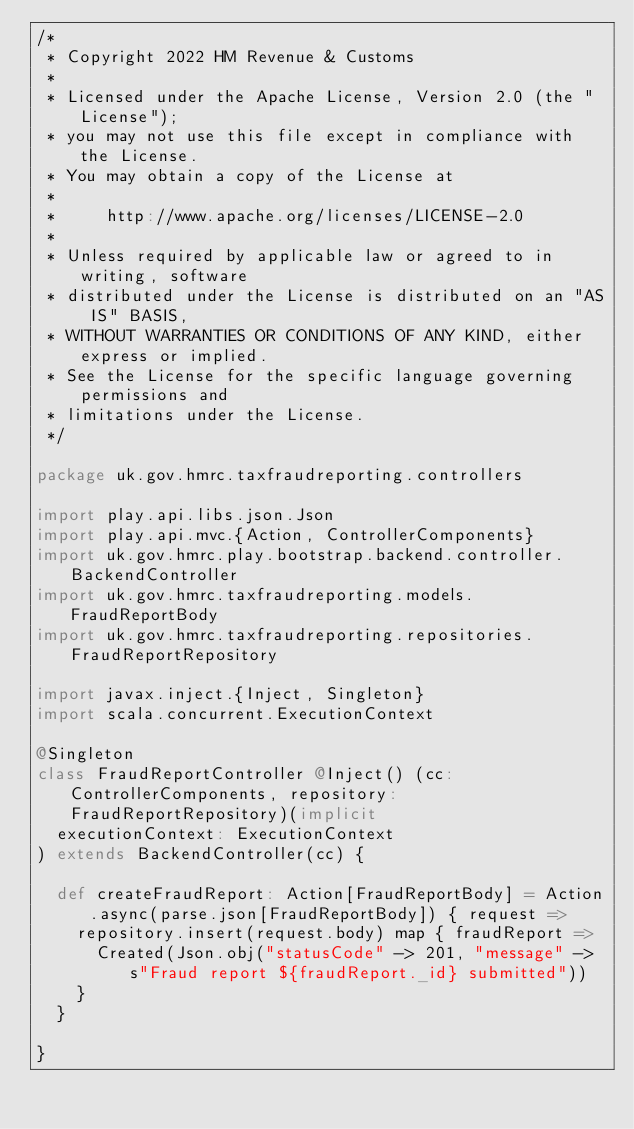<code> <loc_0><loc_0><loc_500><loc_500><_Scala_>/*
 * Copyright 2022 HM Revenue & Customs
 *
 * Licensed under the Apache License, Version 2.0 (the "License");
 * you may not use this file except in compliance with the License.
 * You may obtain a copy of the License at
 *
 *     http://www.apache.org/licenses/LICENSE-2.0
 *
 * Unless required by applicable law or agreed to in writing, software
 * distributed under the License is distributed on an "AS IS" BASIS,
 * WITHOUT WARRANTIES OR CONDITIONS OF ANY KIND, either express or implied.
 * See the License for the specific language governing permissions and
 * limitations under the License.
 */

package uk.gov.hmrc.taxfraudreporting.controllers

import play.api.libs.json.Json
import play.api.mvc.{Action, ControllerComponents}
import uk.gov.hmrc.play.bootstrap.backend.controller.BackendController
import uk.gov.hmrc.taxfraudreporting.models.FraudReportBody
import uk.gov.hmrc.taxfraudreporting.repositories.FraudReportRepository

import javax.inject.{Inject, Singleton}
import scala.concurrent.ExecutionContext

@Singleton
class FraudReportController @Inject() (cc: ControllerComponents, repository: FraudReportRepository)(implicit
  executionContext: ExecutionContext
) extends BackendController(cc) {

  def createFraudReport: Action[FraudReportBody] = Action.async(parse.json[FraudReportBody]) { request =>
    repository.insert(request.body) map { fraudReport =>
      Created(Json.obj("statusCode" -> 201, "message" -> s"Fraud report ${fraudReport._id} submitted"))
    }
  }

}
</code> 